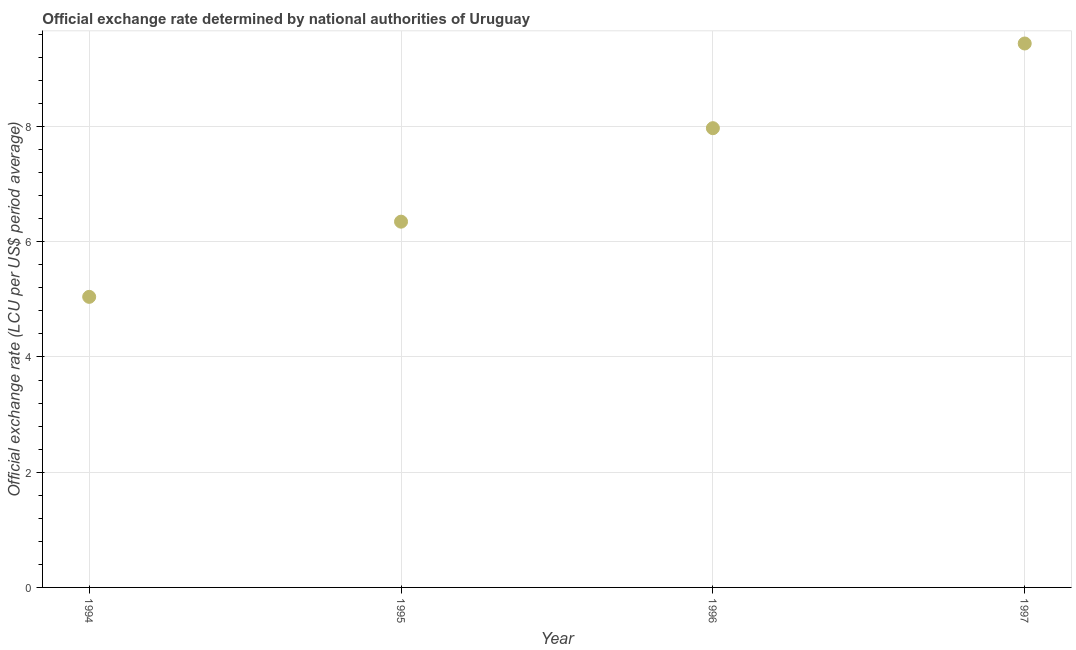What is the official exchange rate in 1995?
Your answer should be compact. 6.35. Across all years, what is the maximum official exchange rate?
Keep it short and to the point. 9.44. Across all years, what is the minimum official exchange rate?
Your response must be concise. 5.04. In which year was the official exchange rate minimum?
Ensure brevity in your answer.  1994. What is the sum of the official exchange rate?
Offer a terse response. 28.81. What is the difference between the official exchange rate in 1995 and 1996?
Offer a terse response. -1.62. What is the average official exchange rate per year?
Give a very brief answer. 7.2. What is the median official exchange rate?
Offer a terse response. 7.16. What is the ratio of the official exchange rate in 1994 to that in 1996?
Keep it short and to the point. 0.63. Is the difference between the official exchange rate in 1994 and 1995 greater than the difference between any two years?
Your response must be concise. No. What is the difference between the highest and the second highest official exchange rate?
Ensure brevity in your answer.  1.47. Is the sum of the official exchange rate in 1994 and 1997 greater than the maximum official exchange rate across all years?
Keep it short and to the point. Yes. What is the difference between the highest and the lowest official exchange rate?
Your answer should be compact. 4.4. In how many years, is the official exchange rate greater than the average official exchange rate taken over all years?
Provide a short and direct response. 2. Does the official exchange rate monotonically increase over the years?
Ensure brevity in your answer.  Yes. Are the values on the major ticks of Y-axis written in scientific E-notation?
Provide a succinct answer. No. Does the graph contain grids?
Your response must be concise. Yes. What is the title of the graph?
Give a very brief answer. Official exchange rate determined by national authorities of Uruguay. What is the label or title of the Y-axis?
Provide a succinct answer. Official exchange rate (LCU per US$ period average). What is the Official exchange rate (LCU per US$ period average) in 1994?
Keep it short and to the point. 5.04. What is the Official exchange rate (LCU per US$ period average) in 1995?
Offer a very short reply. 6.35. What is the Official exchange rate (LCU per US$ period average) in 1996?
Offer a terse response. 7.97. What is the Official exchange rate (LCU per US$ period average) in 1997?
Offer a terse response. 9.44. What is the difference between the Official exchange rate (LCU per US$ period average) in 1994 and 1995?
Your response must be concise. -1.31. What is the difference between the Official exchange rate (LCU per US$ period average) in 1994 and 1996?
Make the answer very short. -2.93. What is the difference between the Official exchange rate (LCU per US$ period average) in 1994 and 1997?
Provide a short and direct response. -4.4. What is the difference between the Official exchange rate (LCU per US$ period average) in 1995 and 1996?
Ensure brevity in your answer.  -1.62. What is the difference between the Official exchange rate (LCU per US$ period average) in 1995 and 1997?
Keep it short and to the point. -3.09. What is the difference between the Official exchange rate (LCU per US$ period average) in 1996 and 1997?
Give a very brief answer. -1.47. What is the ratio of the Official exchange rate (LCU per US$ period average) in 1994 to that in 1995?
Keep it short and to the point. 0.79. What is the ratio of the Official exchange rate (LCU per US$ period average) in 1994 to that in 1996?
Offer a very short reply. 0.63. What is the ratio of the Official exchange rate (LCU per US$ period average) in 1994 to that in 1997?
Keep it short and to the point. 0.53. What is the ratio of the Official exchange rate (LCU per US$ period average) in 1995 to that in 1996?
Ensure brevity in your answer.  0.8. What is the ratio of the Official exchange rate (LCU per US$ period average) in 1995 to that in 1997?
Ensure brevity in your answer.  0.67. What is the ratio of the Official exchange rate (LCU per US$ period average) in 1996 to that in 1997?
Offer a very short reply. 0.84. 